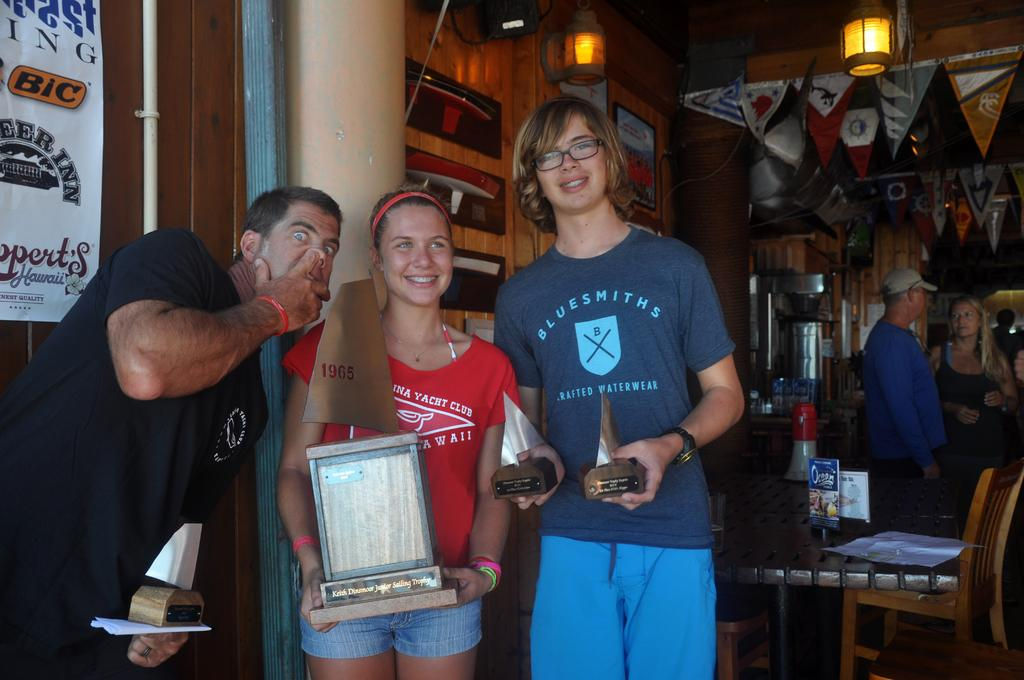How many people are in the image? There is a group of people in the image, but the exact number cannot be determined from the provided facts. What is the primary object in the image? There is a table in the image. What might the people be using to sit? There are chairs in the image. What can be seen in the background of the image? There is a wall, a banner, and some objects visible in the background of the image. How many kittens are sitting on the furniture in the image? There are no kittens or furniture present in the image. 